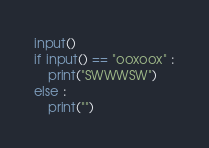<code> <loc_0><loc_0><loc_500><loc_500><_Python_>input()
if input() == "ooxoox" :
    print("SWWWSW")
else :
    print("")</code> 